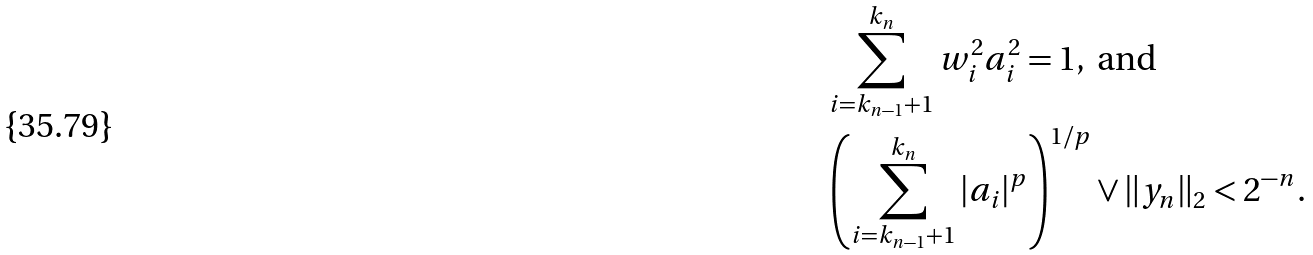Convert formula to latex. <formula><loc_0><loc_0><loc_500><loc_500>& \sum _ { i = k _ { n - 1 } + 1 } ^ { k _ { n } } w _ { i } ^ { 2 } a _ { i } ^ { 2 } = 1 , \text { and} \\ & \left ( \sum _ { i = k _ { n - 1 } + 1 } ^ { k _ { n } } | a _ { i } | ^ { p } \right ) ^ { 1 / p } \vee \| y _ { n } \| _ { 2 } < 2 ^ { - n } .</formula> 